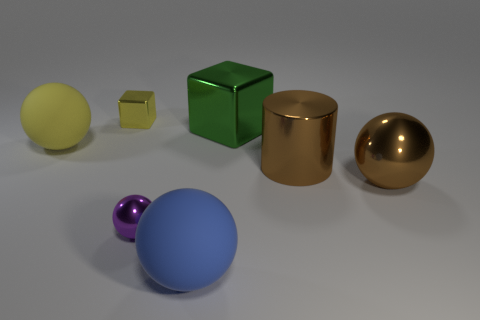Does the brown object in front of the cylinder have the same size as the blue ball?
Your answer should be very brief. Yes. How many things are large yellow balls or large green metallic cubes?
Provide a short and direct response. 2. There is a large object on the left side of the large rubber thing in front of the purple ball that is behind the blue ball; what is its material?
Your answer should be compact. Rubber. There is a big ball on the left side of the large blue matte object; what is it made of?
Your answer should be compact. Rubber. Are there any balls of the same size as the yellow matte object?
Your answer should be compact. Yes. Is the color of the matte sphere that is left of the yellow block the same as the small metal block?
Keep it short and to the point. Yes. What number of purple things are small shiny spheres or cubes?
Ensure brevity in your answer.  1. How many tiny shiny cubes are the same color as the large cylinder?
Offer a terse response. 0. Is the material of the large yellow thing the same as the large cylinder?
Provide a short and direct response. No. What number of objects are right of the rubber thing that is left of the small yellow metallic object?
Make the answer very short. 6. 